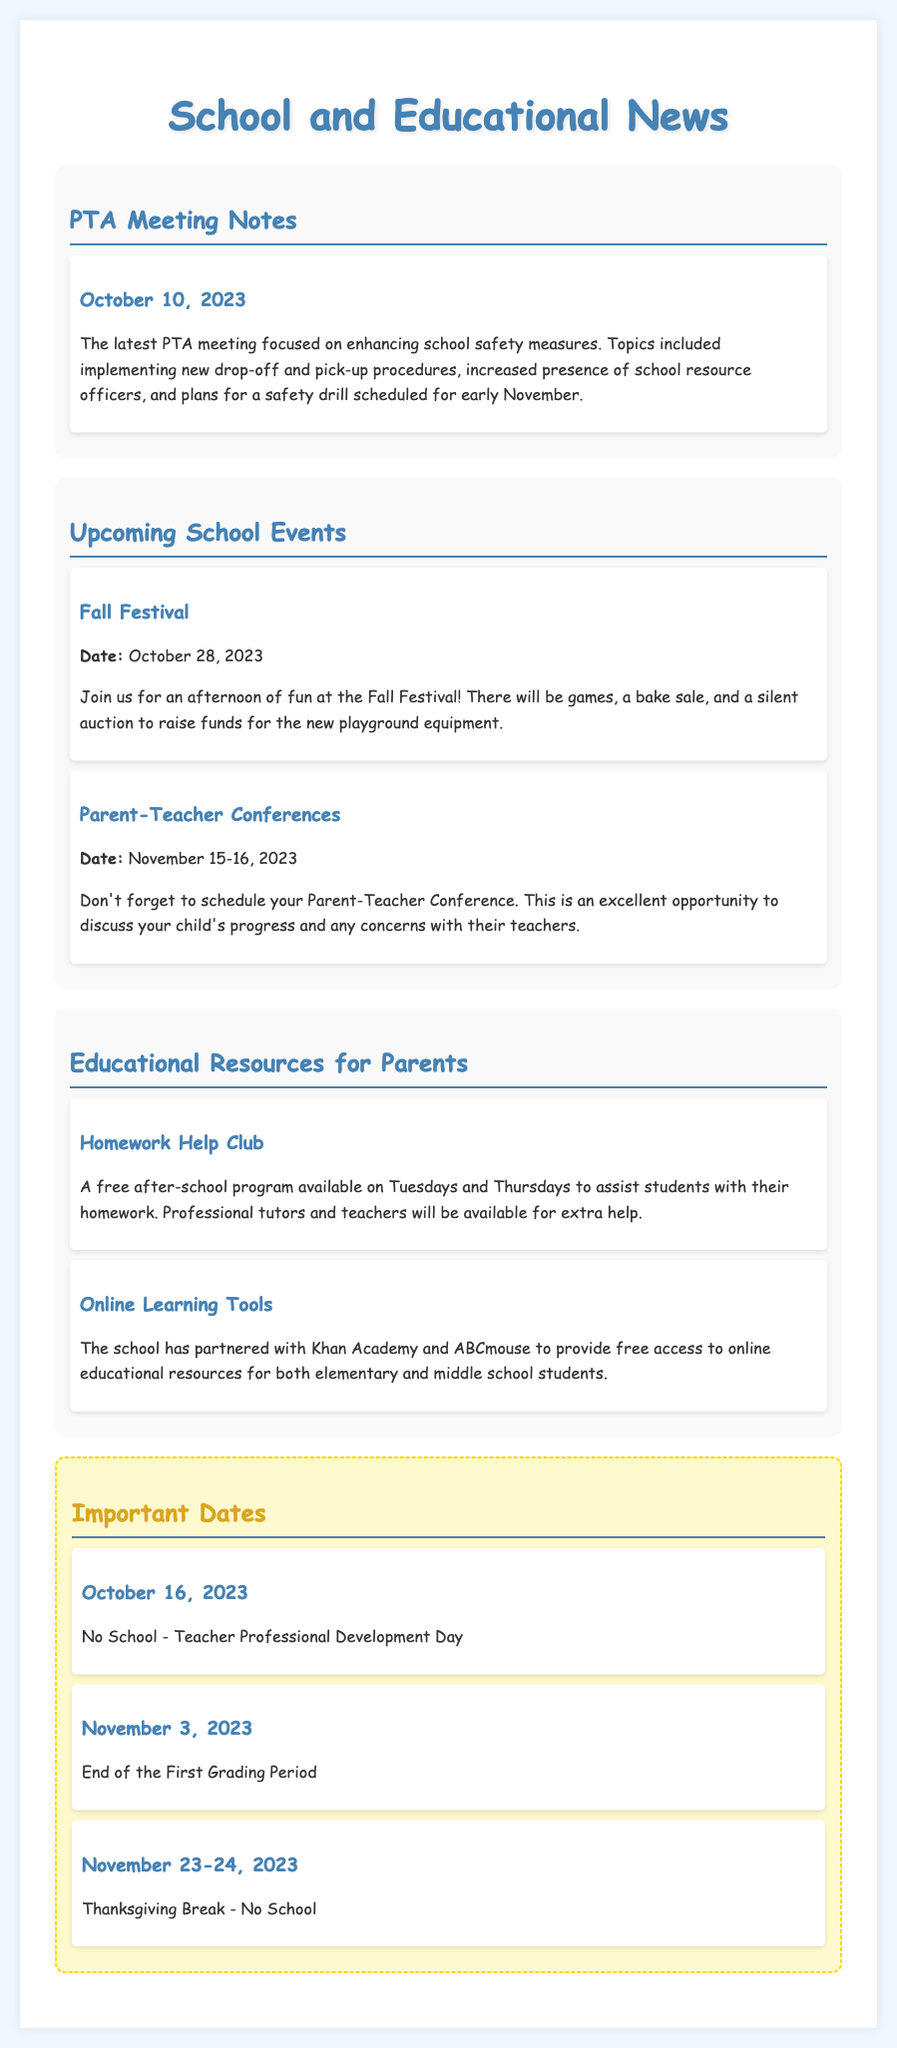What date is the Fall Festival? The Fall Festival is mentioned in the document with the date listed specifically as October 28, 2023.
Answer: October 28, 2023 What is the topic of the latest PTA meeting? The latest PTA meeting discussed enhancing school safety measures, as stated in the meeting notes section.
Answer: School safety measures When are the Parent-Teacher Conferences scheduled? The document lists the dates for Parent-Teacher Conferences as November 15-16, 2023.
Answer: November 15-16, 2023 What resource is available on Tuesdays and Thursdays for students? The document mentions a free after-school program called the Homework Help Club that assists students with their homework.
Answer: Homework Help Club What is the date for the Teacher Professional Development Day? The document specifies that there will be no school on October 16, 2023, for Teacher Professional Development Day.
Answer: October 16, 2023 How many days is the Thanksgiving Break? The document states the Thanksgiving Break lasts for two days, with no school on November 23-24, 2023.
Answer: Two days What type of educational tools are provided online for students? The document states that the school has partnered with Khan Academy and ABCmouse to provide online educational resources.
Answer: Khan Academy and ABCmouse What event is mentioned to raise funds for new playground equipment? The Fall Festival mentioned in the upcoming events section is intended to raise funds for new playground equipment.
Answer: Fall Festival 